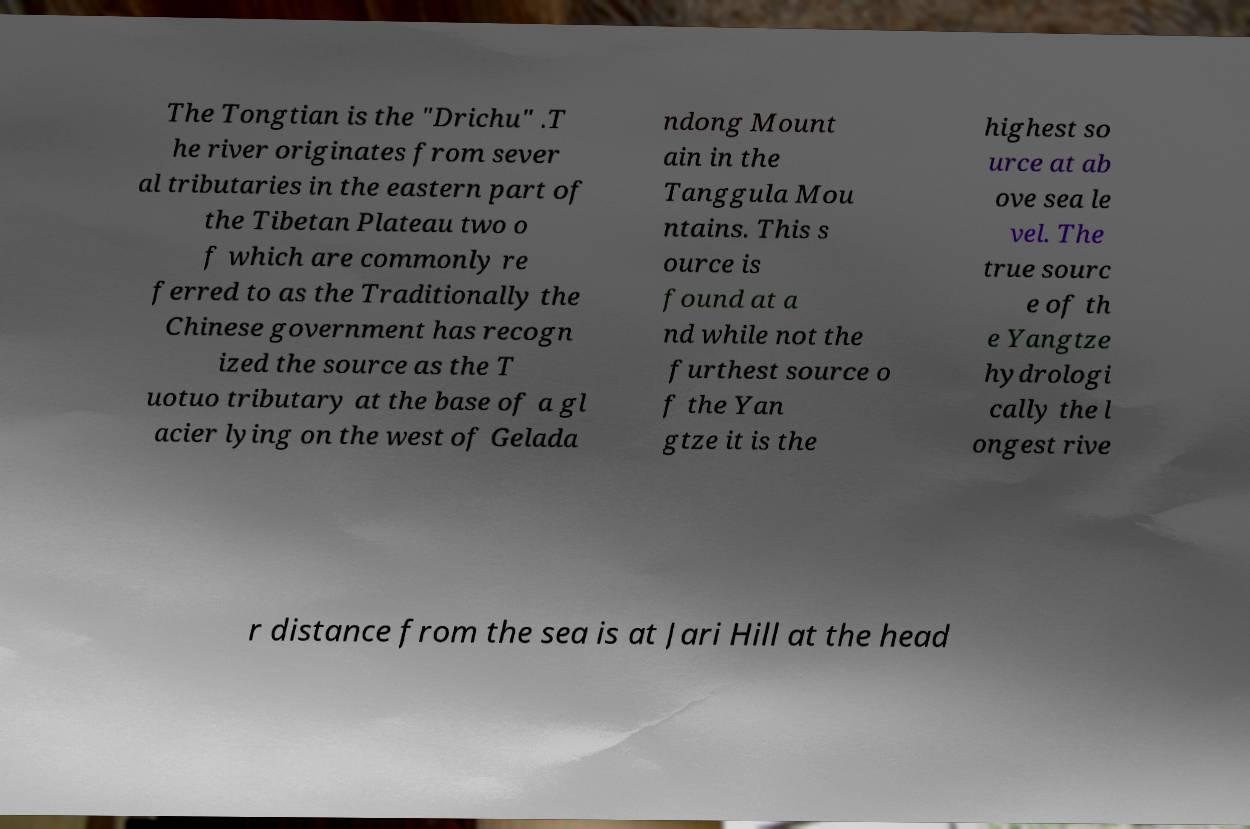Please identify and transcribe the text found in this image. The Tongtian is the "Drichu" .T he river originates from sever al tributaries in the eastern part of the Tibetan Plateau two o f which are commonly re ferred to as the Traditionally the Chinese government has recogn ized the source as the T uotuo tributary at the base of a gl acier lying on the west of Gelada ndong Mount ain in the Tanggula Mou ntains. This s ource is found at a nd while not the furthest source o f the Yan gtze it is the highest so urce at ab ove sea le vel. The true sourc e of th e Yangtze hydrologi cally the l ongest rive r distance from the sea is at Jari Hill at the head 